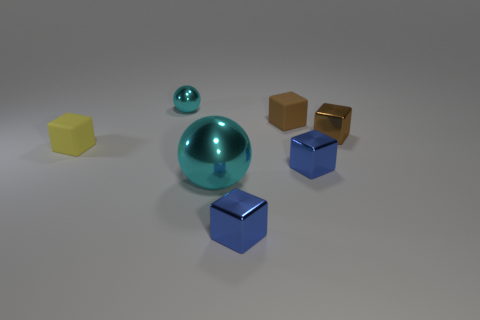The brown matte thing has what size?
Your response must be concise. Small. How many other objects are there of the same color as the large metallic sphere?
Make the answer very short. 1. Does the cyan metal object that is in front of the small yellow thing have the same shape as the brown matte thing?
Ensure brevity in your answer.  No. The other small rubber object that is the same shape as the brown rubber object is what color?
Ensure brevity in your answer.  Yellow. Are there any other things that are made of the same material as the yellow object?
Give a very brief answer. Yes. What is the size of the other rubber thing that is the same shape as the small yellow rubber thing?
Ensure brevity in your answer.  Small. What material is the tiny cube that is both in front of the small yellow cube and behind the large cyan shiny ball?
Give a very brief answer. Metal. Does the small shiny thing that is behind the small brown metal block have the same color as the big metallic thing?
Offer a terse response. Yes. Do the big shiny thing and the small matte cube to the right of the yellow thing have the same color?
Your response must be concise. No. There is a large metallic thing; are there any tiny brown rubber things on the left side of it?
Keep it short and to the point. No. 